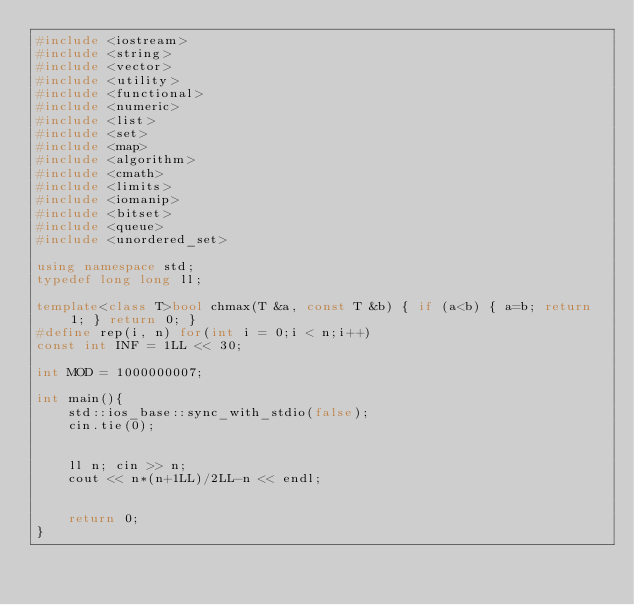Convert code to text. <code><loc_0><loc_0><loc_500><loc_500><_C++_>#include <iostream>
#include <string>
#include <vector>
#include <utility>
#include <functional>
#include <numeric>
#include <list>
#include <set>
#include <map>
#include <algorithm>
#include <cmath>
#include <limits>
#include <iomanip>
#include <bitset>
#include <queue>
#include <unordered_set>

using namespace std;
typedef long long ll;

template<class T>bool chmax(T &a, const T &b) { if (a<b) { a=b; return 1; } return 0; }
#define rep(i, n) for(int i = 0;i < n;i++)
const int INF = 1LL << 30;

int MOD = 1000000007;

int main(){
    std::ios_base::sync_with_stdio(false);
    cin.tie(0);

    
    ll n; cin >> n;
    cout << n*(n+1LL)/2LL-n << endl; 


    return 0;
}</code> 